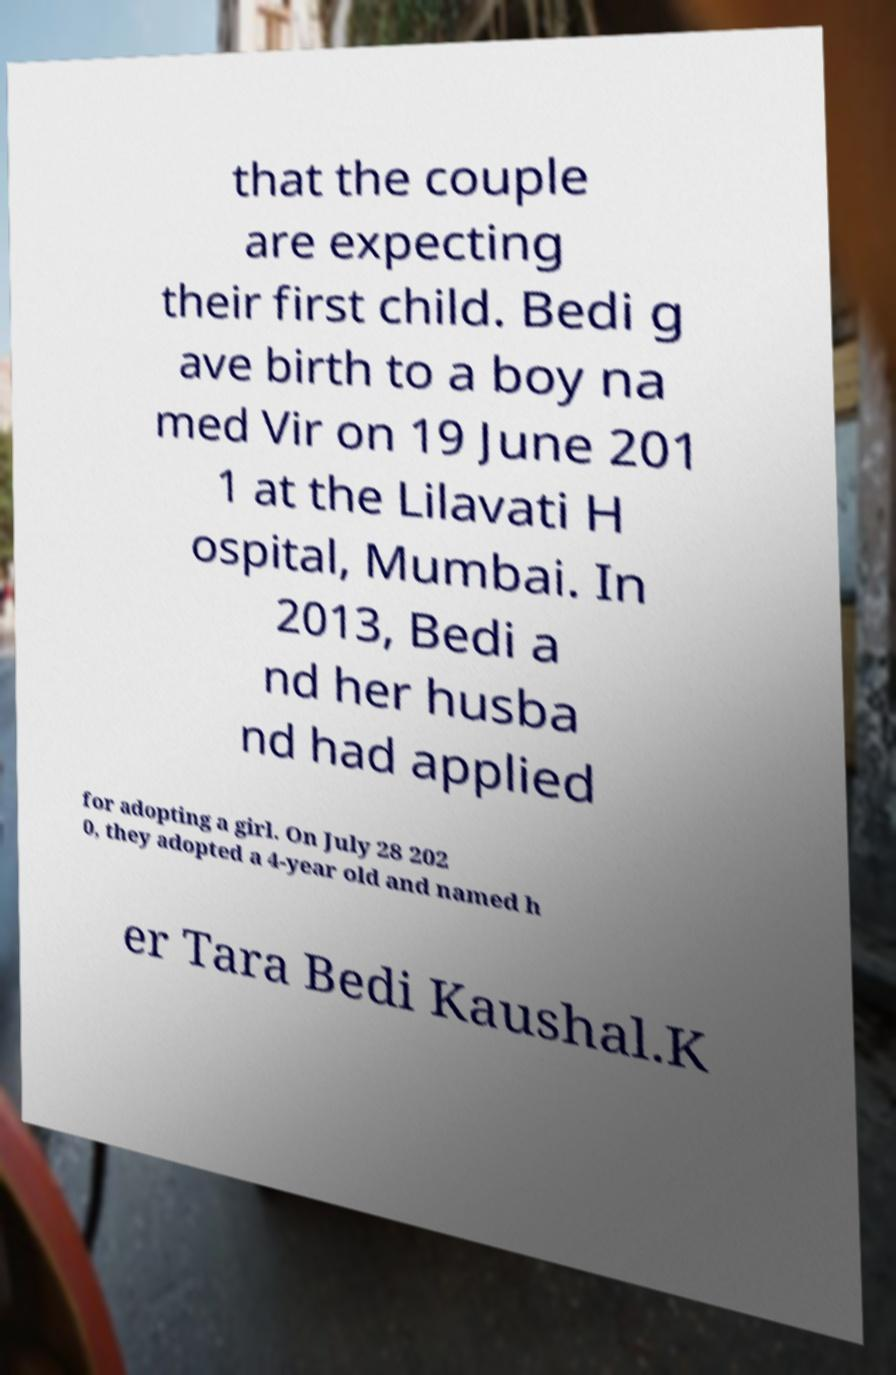There's text embedded in this image that I need extracted. Can you transcribe it verbatim? that the couple are expecting their first child. Bedi g ave birth to a boy na med Vir on 19 June 201 1 at the Lilavati H ospital, Mumbai. In 2013, Bedi a nd her husba nd had applied for adopting a girl. On July 28 202 0, they adopted a 4-year old and named h er Tara Bedi Kaushal.K 